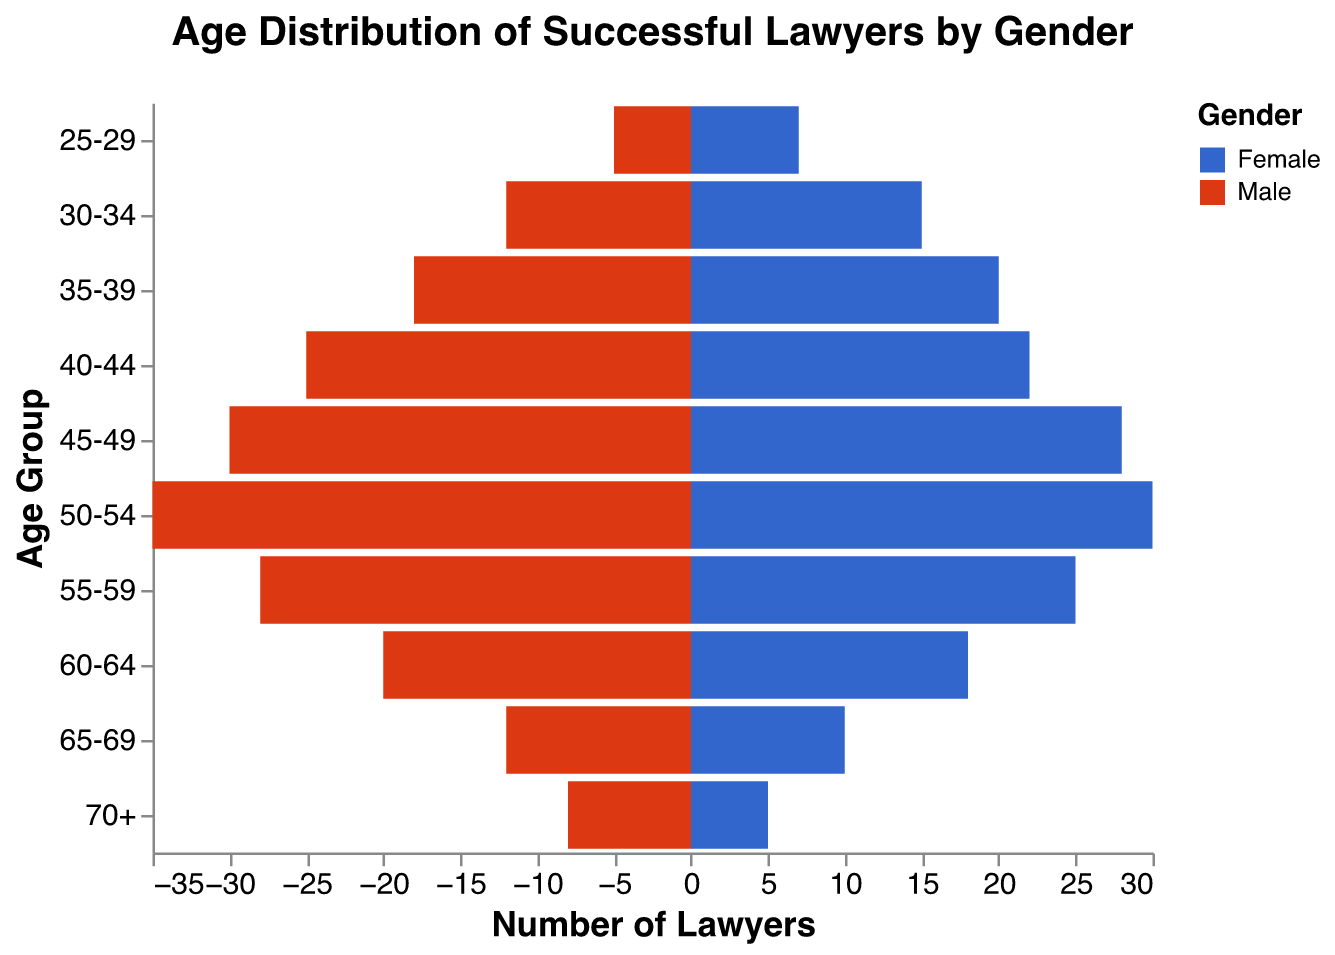What's the title of the figure? The title of the figure is located at the top of the chart and helps viewers quickly understand what the visual is about.
Answer: Age Distribution of Successful Lawyers by Gender Which age group has the highest number of male lawyers? By observing the bars colored for male lawyers (blue), the longest bar corresponds to the 50-54 age group.
Answer: 50-54 Which gender has more lawyers in the 30-34 age group? Compare the lengths of the bars for males and females in the 30-34 age group; the bar representing females (red) is longer.
Answer: Female What is the number of lawyers in the 60-64 age group for both genders combined? Add the number of male lawyers (20) and female lawyers (18) in the 60-64 age group.
Answer: 38 In which age group is the number of female lawyers closest to the number of male lawyers? Find the age group where the difference between the number of male and female lawyers is minimal. The smallest difference is in the 45-49 age group with 30 males and 28 females.
Answer: 45-49 Which age group has the least representation in both genders? Identify the age group with the smallest combined number of lawyers. The 25-29 age group has the fewest with 12 in total (5 males and 7 females).
Answer: 25-29 How many lawyers are there in the 55-59 age group? Sum the number of male (28) and female (25) lawyers in the 55-59 age group.
Answer: 53 Are there more lawyers in the 40-44 or the 65-69 age group? And by how many? Compare the combined totals of each age group: 40-44 has 25 males and 22 females (47 total), 65-69 has 12 males and 10 females (22 total). The difference is 47 - 22.
Answer: 40-44, 25 Compare the number of male and female lawyers in the 35-39 age group. Which is greater and by how much? Subtract the number of male lawyers (18) from the number of female lawyers (20) in the 35-39 age group.
Answer: Female, 2 In which age group is the gender disparity most prominent? The greatest difference between male and female numbers occurs in the 50-54 age group, with 35 males and 30 females, a difference of 5.
Answer: 50-54 